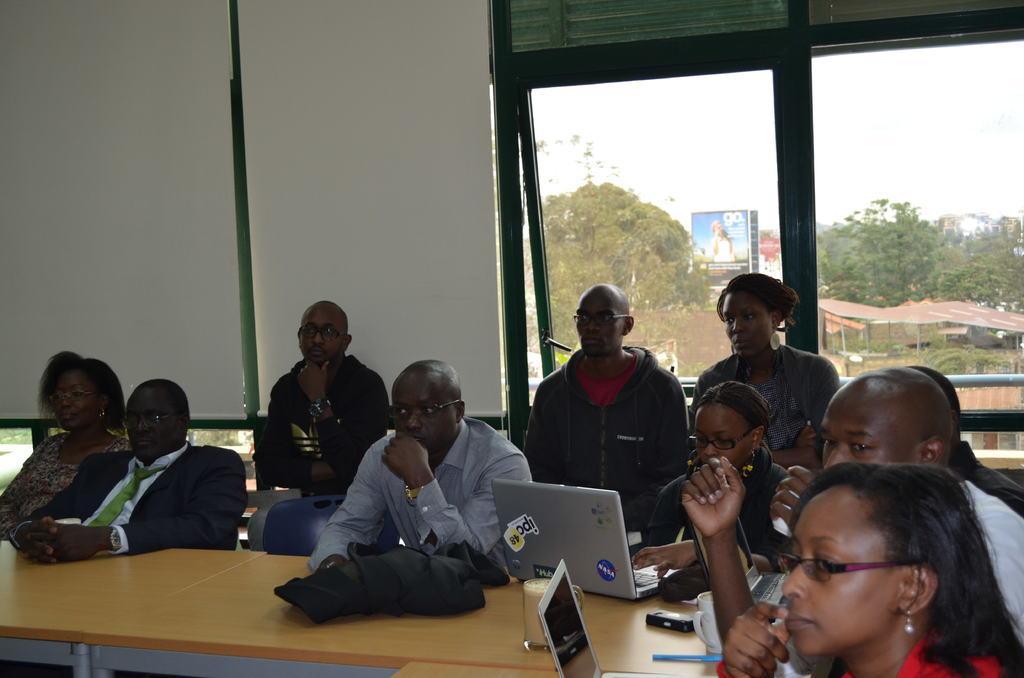In one or two sentences, can you explain what this image depicts? There are few persons sitting on the chairs at the table. On the table we can see cloth, laptops, glass with liquid in it, cup, electronic device and a pen. In the background there is a screen , wall and windows. Through the window glass doors we can see trees, roof, poles, buildings, hoardings and sky. 